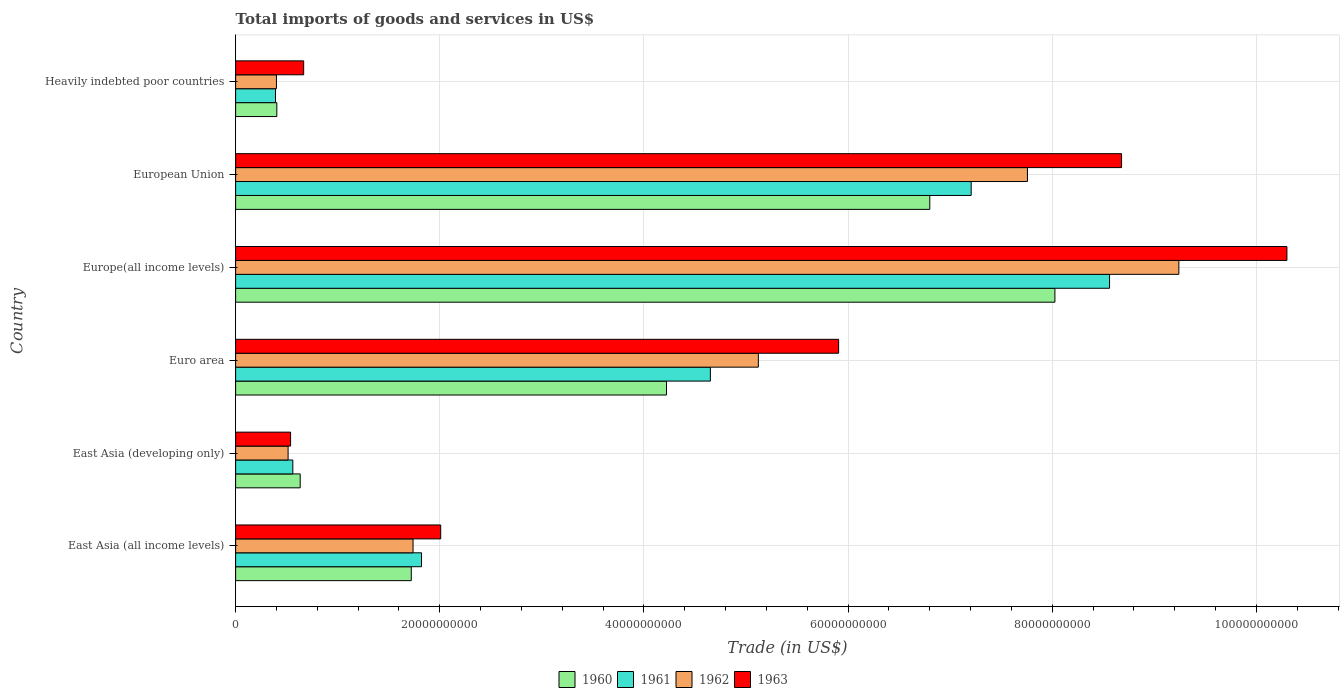How many different coloured bars are there?
Provide a succinct answer. 4. Are the number of bars on each tick of the Y-axis equal?
Your answer should be compact. Yes. How many bars are there on the 4th tick from the top?
Your response must be concise. 4. What is the label of the 1st group of bars from the top?
Provide a succinct answer. Heavily indebted poor countries. In how many cases, is the number of bars for a given country not equal to the number of legend labels?
Provide a short and direct response. 0. What is the total imports of goods and services in 1961 in Heavily indebted poor countries?
Give a very brief answer. 3.91e+09. Across all countries, what is the maximum total imports of goods and services in 1961?
Your answer should be compact. 8.56e+1. Across all countries, what is the minimum total imports of goods and services in 1961?
Ensure brevity in your answer.  3.91e+09. In which country was the total imports of goods and services in 1963 maximum?
Provide a short and direct response. Europe(all income levels). In which country was the total imports of goods and services in 1962 minimum?
Provide a succinct answer. Heavily indebted poor countries. What is the total total imports of goods and services in 1960 in the graph?
Make the answer very short. 2.18e+11. What is the difference between the total imports of goods and services in 1960 in East Asia (developing only) and that in Heavily indebted poor countries?
Give a very brief answer. 2.29e+09. What is the difference between the total imports of goods and services in 1962 in East Asia (developing only) and the total imports of goods and services in 1963 in East Asia (all income levels)?
Keep it short and to the point. -1.50e+1. What is the average total imports of goods and services in 1960 per country?
Your response must be concise. 3.63e+1. What is the difference between the total imports of goods and services in 1961 and total imports of goods and services in 1960 in East Asia (all income levels)?
Offer a terse response. 1.00e+09. What is the ratio of the total imports of goods and services in 1960 in Euro area to that in Heavily indebted poor countries?
Provide a short and direct response. 10.45. Is the total imports of goods and services in 1962 in Europe(all income levels) less than that in European Union?
Provide a short and direct response. No. What is the difference between the highest and the second highest total imports of goods and services in 1962?
Provide a short and direct response. 1.48e+1. What is the difference between the highest and the lowest total imports of goods and services in 1960?
Offer a very short reply. 7.62e+1. Is it the case that in every country, the sum of the total imports of goods and services in 1963 and total imports of goods and services in 1960 is greater than the sum of total imports of goods and services in 1961 and total imports of goods and services in 1962?
Make the answer very short. No. What does the 2nd bar from the top in East Asia (developing only) represents?
Your answer should be compact. 1962. What does the 4th bar from the bottom in East Asia (all income levels) represents?
Provide a short and direct response. 1963. Is it the case that in every country, the sum of the total imports of goods and services in 1963 and total imports of goods and services in 1960 is greater than the total imports of goods and services in 1962?
Offer a terse response. Yes. How many bars are there?
Provide a short and direct response. 24. How many countries are there in the graph?
Offer a terse response. 6. Does the graph contain any zero values?
Ensure brevity in your answer.  No. How many legend labels are there?
Ensure brevity in your answer.  4. What is the title of the graph?
Your answer should be compact. Total imports of goods and services in US$. Does "1962" appear as one of the legend labels in the graph?
Your answer should be compact. Yes. What is the label or title of the X-axis?
Make the answer very short. Trade (in US$). What is the Trade (in US$) of 1960 in East Asia (all income levels)?
Your answer should be compact. 1.72e+1. What is the Trade (in US$) of 1961 in East Asia (all income levels)?
Provide a succinct answer. 1.82e+1. What is the Trade (in US$) in 1962 in East Asia (all income levels)?
Make the answer very short. 1.74e+1. What is the Trade (in US$) of 1963 in East Asia (all income levels)?
Offer a terse response. 2.01e+1. What is the Trade (in US$) of 1960 in East Asia (developing only)?
Offer a terse response. 6.33e+09. What is the Trade (in US$) of 1961 in East Asia (developing only)?
Ensure brevity in your answer.  5.60e+09. What is the Trade (in US$) in 1962 in East Asia (developing only)?
Provide a succinct answer. 5.14e+09. What is the Trade (in US$) in 1963 in East Asia (developing only)?
Ensure brevity in your answer.  5.39e+09. What is the Trade (in US$) in 1960 in Euro area?
Offer a very short reply. 4.22e+1. What is the Trade (in US$) in 1961 in Euro area?
Your answer should be very brief. 4.65e+1. What is the Trade (in US$) of 1962 in Euro area?
Provide a short and direct response. 5.12e+1. What is the Trade (in US$) of 1963 in Euro area?
Offer a terse response. 5.91e+1. What is the Trade (in US$) of 1960 in Europe(all income levels)?
Offer a very short reply. 8.03e+1. What is the Trade (in US$) in 1961 in Europe(all income levels)?
Make the answer very short. 8.56e+1. What is the Trade (in US$) in 1962 in Europe(all income levels)?
Keep it short and to the point. 9.24e+1. What is the Trade (in US$) in 1963 in Europe(all income levels)?
Ensure brevity in your answer.  1.03e+11. What is the Trade (in US$) in 1960 in European Union?
Keep it short and to the point. 6.80e+1. What is the Trade (in US$) of 1961 in European Union?
Your answer should be compact. 7.21e+1. What is the Trade (in US$) of 1962 in European Union?
Your answer should be compact. 7.76e+1. What is the Trade (in US$) in 1963 in European Union?
Give a very brief answer. 8.68e+1. What is the Trade (in US$) in 1960 in Heavily indebted poor countries?
Provide a succinct answer. 4.04e+09. What is the Trade (in US$) of 1961 in Heavily indebted poor countries?
Your answer should be very brief. 3.91e+09. What is the Trade (in US$) of 1962 in Heavily indebted poor countries?
Provide a short and direct response. 4.00e+09. What is the Trade (in US$) in 1963 in Heavily indebted poor countries?
Provide a short and direct response. 6.67e+09. Across all countries, what is the maximum Trade (in US$) of 1960?
Ensure brevity in your answer.  8.03e+1. Across all countries, what is the maximum Trade (in US$) of 1961?
Your answer should be compact. 8.56e+1. Across all countries, what is the maximum Trade (in US$) of 1962?
Provide a short and direct response. 9.24e+1. Across all countries, what is the maximum Trade (in US$) of 1963?
Ensure brevity in your answer.  1.03e+11. Across all countries, what is the minimum Trade (in US$) in 1960?
Ensure brevity in your answer.  4.04e+09. Across all countries, what is the minimum Trade (in US$) of 1961?
Provide a short and direct response. 3.91e+09. Across all countries, what is the minimum Trade (in US$) of 1962?
Your answer should be compact. 4.00e+09. Across all countries, what is the minimum Trade (in US$) of 1963?
Keep it short and to the point. 5.39e+09. What is the total Trade (in US$) in 1960 in the graph?
Your answer should be compact. 2.18e+11. What is the total Trade (in US$) in 1961 in the graph?
Provide a succinct answer. 2.32e+11. What is the total Trade (in US$) in 1962 in the graph?
Offer a terse response. 2.48e+11. What is the total Trade (in US$) in 1963 in the graph?
Offer a very short reply. 2.81e+11. What is the difference between the Trade (in US$) in 1960 in East Asia (all income levels) and that in East Asia (developing only)?
Offer a very short reply. 1.09e+1. What is the difference between the Trade (in US$) in 1961 in East Asia (all income levels) and that in East Asia (developing only)?
Offer a very short reply. 1.26e+1. What is the difference between the Trade (in US$) of 1962 in East Asia (all income levels) and that in East Asia (developing only)?
Keep it short and to the point. 1.22e+1. What is the difference between the Trade (in US$) in 1963 in East Asia (all income levels) and that in East Asia (developing only)?
Ensure brevity in your answer.  1.47e+1. What is the difference between the Trade (in US$) in 1960 in East Asia (all income levels) and that in Euro area?
Keep it short and to the point. -2.50e+1. What is the difference between the Trade (in US$) in 1961 in East Asia (all income levels) and that in Euro area?
Your answer should be compact. -2.83e+1. What is the difference between the Trade (in US$) of 1962 in East Asia (all income levels) and that in Euro area?
Ensure brevity in your answer.  -3.38e+1. What is the difference between the Trade (in US$) of 1963 in East Asia (all income levels) and that in Euro area?
Offer a terse response. -3.90e+1. What is the difference between the Trade (in US$) of 1960 in East Asia (all income levels) and that in Europe(all income levels)?
Your answer should be compact. -6.31e+1. What is the difference between the Trade (in US$) in 1961 in East Asia (all income levels) and that in Europe(all income levels)?
Offer a terse response. -6.74e+1. What is the difference between the Trade (in US$) of 1962 in East Asia (all income levels) and that in Europe(all income levels)?
Ensure brevity in your answer.  -7.50e+1. What is the difference between the Trade (in US$) in 1963 in East Asia (all income levels) and that in Europe(all income levels)?
Give a very brief answer. -8.29e+1. What is the difference between the Trade (in US$) in 1960 in East Asia (all income levels) and that in European Union?
Provide a short and direct response. -5.08e+1. What is the difference between the Trade (in US$) in 1961 in East Asia (all income levels) and that in European Union?
Offer a very short reply. -5.38e+1. What is the difference between the Trade (in US$) in 1962 in East Asia (all income levels) and that in European Union?
Make the answer very short. -6.02e+1. What is the difference between the Trade (in US$) in 1963 in East Asia (all income levels) and that in European Union?
Your answer should be very brief. -6.67e+1. What is the difference between the Trade (in US$) in 1960 in East Asia (all income levels) and that in Heavily indebted poor countries?
Your answer should be compact. 1.32e+1. What is the difference between the Trade (in US$) in 1961 in East Asia (all income levels) and that in Heavily indebted poor countries?
Provide a short and direct response. 1.43e+1. What is the difference between the Trade (in US$) of 1962 in East Asia (all income levels) and that in Heavily indebted poor countries?
Your answer should be very brief. 1.34e+1. What is the difference between the Trade (in US$) in 1963 in East Asia (all income levels) and that in Heavily indebted poor countries?
Your answer should be compact. 1.34e+1. What is the difference between the Trade (in US$) of 1960 in East Asia (developing only) and that in Euro area?
Offer a terse response. -3.59e+1. What is the difference between the Trade (in US$) of 1961 in East Asia (developing only) and that in Euro area?
Keep it short and to the point. -4.09e+1. What is the difference between the Trade (in US$) in 1962 in East Asia (developing only) and that in Euro area?
Your answer should be very brief. -4.61e+1. What is the difference between the Trade (in US$) of 1963 in East Asia (developing only) and that in Euro area?
Ensure brevity in your answer.  -5.37e+1. What is the difference between the Trade (in US$) in 1960 in East Asia (developing only) and that in Europe(all income levels)?
Offer a very short reply. -7.39e+1. What is the difference between the Trade (in US$) of 1961 in East Asia (developing only) and that in Europe(all income levels)?
Provide a succinct answer. -8.00e+1. What is the difference between the Trade (in US$) of 1962 in East Asia (developing only) and that in Europe(all income levels)?
Offer a terse response. -8.73e+1. What is the difference between the Trade (in US$) in 1963 in East Asia (developing only) and that in Europe(all income levels)?
Offer a very short reply. -9.76e+1. What is the difference between the Trade (in US$) of 1960 in East Asia (developing only) and that in European Union?
Provide a short and direct response. -6.17e+1. What is the difference between the Trade (in US$) of 1961 in East Asia (developing only) and that in European Union?
Keep it short and to the point. -6.65e+1. What is the difference between the Trade (in US$) of 1962 in East Asia (developing only) and that in European Union?
Provide a short and direct response. -7.24e+1. What is the difference between the Trade (in US$) in 1963 in East Asia (developing only) and that in European Union?
Provide a short and direct response. -8.14e+1. What is the difference between the Trade (in US$) of 1960 in East Asia (developing only) and that in Heavily indebted poor countries?
Offer a terse response. 2.29e+09. What is the difference between the Trade (in US$) of 1961 in East Asia (developing only) and that in Heavily indebted poor countries?
Your answer should be very brief. 1.70e+09. What is the difference between the Trade (in US$) in 1962 in East Asia (developing only) and that in Heavily indebted poor countries?
Provide a short and direct response. 1.14e+09. What is the difference between the Trade (in US$) in 1963 in East Asia (developing only) and that in Heavily indebted poor countries?
Your answer should be compact. -1.28e+09. What is the difference between the Trade (in US$) of 1960 in Euro area and that in Europe(all income levels)?
Your response must be concise. -3.80e+1. What is the difference between the Trade (in US$) in 1961 in Euro area and that in Europe(all income levels)?
Ensure brevity in your answer.  -3.91e+1. What is the difference between the Trade (in US$) of 1962 in Euro area and that in Europe(all income levels)?
Your answer should be compact. -4.12e+1. What is the difference between the Trade (in US$) of 1963 in Euro area and that in Europe(all income levels)?
Provide a succinct answer. -4.39e+1. What is the difference between the Trade (in US$) in 1960 in Euro area and that in European Union?
Your response must be concise. -2.58e+1. What is the difference between the Trade (in US$) of 1961 in Euro area and that in European Union?
Offer a terse response. -2.56e+1. What is the difference between the Trade (in US$) in 1962 in Euro area and that in European Union?
Keep it short and to the point. -2.64e+1. What is the difference between the Trade (in US$) of 1963 in Euro area and that in European Union?
Offer a terse response. -2.77e+1. What is the difference between the Trade (in US$) in 1960 in Euro area and that in Heavily indebted poor countries?
Your answer should be very brief. 3.82e+1. What is the difference between the Trade (in US$) of 1961 in Euro area and that in Heavily indebted poor countries?
Your answer should be compact. 4.26e+1. What is the difference between the Trade (in US$) of 1962 in Euro area and that in Heavily indebted poor countries?
Offer a terse response. 4.72e+1. What is the difference between the Trade (in US$) in 1963 in Euro area and that in Heavily indebted poor countries?
Your answer should be very brief. 5.24e+1. What is the difference between the Trade (in US$) in 1960 in Europe(all income levels) and that in European Union?
Provide a succinct answer. 1.23e+1. What is the difference between the Trade (in US$) in 1961 in Europe(all income levels) and that in European Union?
Offer a terse response. 1.36e+1. What is the difference between the Trade (in US$) in 1962 in Europe(all income levels) and that in European Union?
Your answer should be compact. 1.48e+1. What is the difference between the Trade (in US$) in 1963 in Europe(all income levels) and that in European Union?
Give a very brief answer. 1.62e+1. What is the difference between the Trade (in US$) of 1960 in Europe(all income levels) and that in Heavily indebted poor countries?
Give a very brief answer. 7.62e+1. What is the difference between the Trade (in US$) in 1961 in Europe(all income levels) and that in Heavily indebted poor countries?
Keep it short and to the point. 8.17e+1. What is the difference between the Trade (in US$) in 1962 in Europe(all income levels) and that in Heavily indebted poor countries?
Offer a terse response. 8.84e+1. What is the difference between the Trade (in US$) in 1963 in Europe(all income levels) and that in Heavily indebted poor countries?
Your answer should be very brief. 9.63e+1. What is the difference between the Trade (in US$) of 1960 in European Union and that in Heavily indebted poor countries?
Offer a very short reply. 6.40e+1. What is the difference between the Trade (in US$) of 1961 in European Union and that in Heavily indebted poor countries?
Provide a short and direct response. 6.82e+1. What is the difference between the Trade (in US$) of 1962 in European Union and that in Heavily indebted poor countries?
Ensure brevity in your answer.  7.36e+1. What is the difference between the Trade (in US$) in 1963 in European Union and that in Heavily indebted poor countries?
Keep it short and to the point. 8.01e+1. What is the difference between the Trade (in US$) in 1960 in East Asia (all income levels) and the Trade (in US$) in 1961 in East Asia (developing only)?
Your answer should be very brief. 1.16e+1. What is the difference between the Trade (in US$) of 1960 in East Asia (all income levels) and the Trade (in US$) of 1962 in East Asia (developing only)?
Your answer should be very brief. 1.21e+1. What is the difference between the Trade (in US$) in 1960 in East Asia (all income levels) and the Trade (in US$) in 1963 in East Asia (developing only)?
Your answer should be compact. 1.18e+1. What is the difference between the Trade (in US$) in 1961 in East Asia (all income levels) and the Trade (in US$) in 1962 in East Asia (developing only)?
Give a very brief answer. 1.31e+1. What is the difference between the Trade (in US$) of 1961 in East Asia (all income levels) and the Trade (in US$) of 1963 in East Asia (developing only)?
Keep it short and to the point. 1.28e+1. What is the difference between the Trade (in US$) of 1962 in East Asia (all income levels) and the Trade (in US$) of 1963 in East Asia (developing only)?
Give a very brief answer. 1.20e+1. What is the difference between the Trade (in US$) of 1960 in East Asia (all income levels) and the Trade (in US$) of 1961 in Euro area?
Your answer should be very brief. -2.93e+1. What is the difference between the Trade (in US$) in 1960 in East Asia (all income levels) and the Trade (in US$) in 1962 in Euro area?
Ensure brevity in your answer.  -3.40e+1. What is the difference between the Trade (in US$) of 1960 in East Asia (all income levels) and the Trade (in US$) of 1963 in Euro area?
Keep it short and to the point. -4.19e+1. What is the difference between the Trade (in US$) of 1961 in East Asia (all income levels) and the Trade (in US$) of 1962 in Euro area?
Offer a very short reply. -3.30e+1. What is the difference between the Trade (in US$) in 1961 in East Asia (all income levels) and the Trade (in US$) in 1963 in Euro area?
Make the answer very short. -4.09e+1. What is the difference between the Trade (in US$) of 1962 in East Asia (all income levels) and the Trade (in US$) of 1963 in Euro area?
Give a very brief answer. -4.17e+1. What is the difference between the Trade (in US$) of 1960 in East Asia (all income levels) and the Trade (in US$) of 1961 in Europe(all income levels)?
Your answer should be compact. -6.84e+1. What is the difference between the Trade (in US$) in 1960 in East Asia (all income levels) and the Trade (in US$) in 1962 in Europe(all income levels)?
Your response must be concise. -7.52e+1. What is the difference between the Trade (in US$) in 1960 in East Asia (all income levels) and the Trade (in US$) in 1963 in Europe(all income levels)?
Your response must be concise. -8.58e+1. What is the difference between the Trade (in US$) in 1961 in East Asia (all income levels) and the Trade (in US$) in 1962 in Europe(all income levels)?
Provide a short and direct response. -7.42e+1. What is the difference between the Trade (in US$) of 1961 in East Asia (all income levels) and the Trade (in US$) of 1963 in Europe(all income levels)?
Provide a short and direct response. -8.48e+1. What is the difference between the Trade (in US$) in 1962 in East Asia (all income levels) and the Trade (in US$) in 1963 in Europe(all income levels)?
Your response must be concise. -8.56e+1. What is the difference between the Trade (in US$) of 1960 in East Asia (all income levels) and the Trade (in US$) of 1961 in European Union?
Give a very brief answer. -5.49e+1. What is the difference between the Trade (in US$) of 1960 in East Asia (all income levels) and the Trade (in US$) of 1962 in European Union?
Ensure brevity in your answer.  -6.04e+1. What is the difference between the Trade (in US$) of 1960 in East Asia (all income levels) and the Trade (in US$) of 1963 in European Union?
Your answer should be very brief. -6.96e+1. What is the difference between the Trade (in US$) in 1961 in East Asia (all income levels) and the Trade (in US$) in 1962 in European Union?
Provide a succinct answer. -5.94e+1. What is the difference between the Trade (in US$) in 1961 in East Asia (all income levels) and the Trade (in US$) in 1963 in European Union?
Your answer should be very brief. -6.86e+1. What is the difference between the Trade (in US$) in 1962 in East Asia (all income levels) and the Trade (in US$) in 1963 in European Union?
Offer a terse response. -6.94e+1. What is the difference between the Trade (in US$) in 1960 in East Asia (all income levels) and the Trade (in US$) in 1961 in Heavily indebted poor countries?
Make the answer very short. 1.33e+1. What is the difference between the Trade (in US$) in 1960 in East Asia (all income levels) and the Trade (in US$) in 1962 in Heavily indebted poor countries?
Your response must be concise. 1.32e+1. What is the difference between the Trade (in US$) of 1960 in East Asia (all income levels) and the Trade (in US$) of 1963 in Heavily indebted poor countries?
Make the answer very short. 1.05e+1. What is the difference between the Trade (in US$) in 1961 in East Asia (all income levels) and the Trade (in US$) in 1962 in Heavily indebted poor countries?
Ensure brevity in your answer.  1.42e+1. What is the difference between the Trade (in US$) of 1961 in East Asia (all income levels) and the Trade (in US$) of 1963 in Heavily indebted poor countries?
Your answer should be very brief. 1.15e+1. What is the difference between the Trade (in US$) of 1962 in East Asia (all income levels) and the Trade (in US$) of 1963 in Heavily indebted poor countries?
Keep it short and to the point. 1.07e+1. What is the difference between the Trade (in US$) in 1960 in East Asia (developing only) and the Trade (in US$) in 1961 in Euro area?
Provide a short and direct response. -4.02e+1. What is the difference between the Trade (in US$) of 1960 in East Asia (developing only) and the Trade (in US$) of 1962 in Euro area?
Your response must be concise. -4.49e+1. What is the difference between the Trade (in US$) of 1960 in East Asia (developing only) and the Trade (in US$) of 1963 in Euro area?
Give a very brief answer. -5.27e+1. What is the difference between the Trade (in US$) in 1961 in East Asia (developing only) and the Trade (in US$) in 1962 in Euro area?
Provide a succinct answer. -4.56e+1. What is the difference between the Trade (in US$) in 1961 in East Asia (developing only) and the Trade (in US$) in 1963 in Euro area?
Make the answer very short. -5.35e+1. What is the difference between the Trade (in US$) of 1962 in East Asia (developing only) and the Trade (in US$) of 1963 in Euro area?
Make the answer very short. -5.39e+1. What is the difference between the Trade (in US$) in 1960 in East Asia (developing only) and the Trade (in US$) in 1961 in Europe(all income levels)?
Make the answer very short. -7.93e+1. What is the difference between the Trade (in US$) of 1960 in East Asia (developing only) and the Trade (in US$) of 1962 in Europe(all income levels)?
Provide a succinct answer. -8.61e+1. What is the difference between the Trade (in US$) in 1960 in East Asia (developing only) and the Trade (in US$) in 1963 in Europe(all income levels)?
Your answer should be very brief. -9.67e+1. What is the difference between the Trade (in US$) of 1961 in East Asia (developing only) and the Trade (in US$) of 1962 in Europe(all income levels)?
Your answer should be very brief. -8.68e+1. What is the difference between the Trade (in US$) of 1961 in East Asia (developing only) and the Trade (in US$) of 1963 in Europe(all income levels)?
Your answer should be very brief. -9.74e+1. What is the difference between the Trade (in US$) of 1962 in East Asia (developing only) and the Trade (in US$) of 1963 in Europe(all income levels)?
Offer a terse response. -9.79e+1. What is the difference between the Trade (in US$) of 1960 in East Asia (developing only) and the Trade (in US$) of 1961 in European Union?
Keep it short and to the point. -6.57e+1. What is the difference between the Trade (in US$) of 1960 in East Asia (developing only) and the Trade (in US$) of 1962 in European Union?
Your response must be concise. -7.12e+1. What is the difference between the Trade (in US$) in 1960 in East Asia (developing only) and the Trade (in US$) in 1963 in European Union?
Ensure brevity in your answer.  -8.05e+1. What is the difference between the Trade (in US$) of 1961 in East Asia (developing only) and the Trade (in US$) of 1962 in European Union?
Your answer should be very brief. -7.20e+1. What is the difference between the Trade (in US$) of 1961 in East Asia (developing only) and the Trade (in US$) of 1963 in European Union?
Your response must be concise. -8.12e+1. What is the difference between the Trade (in US$) in 1962 in East Asia (developing only) and the Trade (in US$) in 1963 in European Union?
Provide a succinct answer. -8.17e+1. What is the difference between the Trade (in US$) in 1960 in East Asia (developing only) and the Trade (in US$) in 1961 in Heavily indebted poor countries?
Ensure brevity in your answer.  2.42e+09. What is the difference between the Trade (in US$) in 1960 in East Asia (developing only) and the Trade (in US$) in 1962 in Heavily indebted poor countries?
Provide a short and direct response. 2.33e+09. What is the difference between the Trade (in US$) of 1960 in East Asia (developing only) and the Trade (in US$) of 1963 in Heavily indebted poor countries?
Your answer should be very brief. -3.39e+08. What is the difference between the Trade (in US$) in 1961 in East Asia (developing only) and the Trade (in US$) in 1962 in Heavily indebted poor countries?
Give a very brief answer. 1.61e+09. What is the difference between the Trade (in US$) in 1961 in East Asia (developing only) and the Trade (in US$) in 1963 in Heavily indebted poor countries?
Give a very brief answer. -1.06e+09. What is the difference between the Trade (in US$) of 1962 in East Asia (developing only) and the Trade (in US$) of 1963 in Heavily indebted poor countries?
Give a very brief answer. -1.53e+09. What is the difference between the Trade (in US$) in 1960 in Euro area and the Trade (in US$) in 1961 in Europe(all income levels)?
Offer a terse response. -4.34e+1. What is the difference between the Trade (in US$) of 1960 in Euro area and the Trade (in US$) of 1962 in Europe(all income levels)?
Provide a short and direct response. -5.02e+1. What is the difference between the Trade (in US$) in 1960 in Euro area and the Trade (in US$) in 1963 in Europe(all income levels)?
Make the answer very short. -6.08e+1. What is the difference between the Trade (in US$) in 1961 in Euro area and the Trade (in US$) in 1962 in Europe(all income levels)?
Provide a succinct answer. -4.59e+1. What is the difference between the Trade (in US$) in 1961 in Euro area and the Trade (in US$) in 1963 in Europe(all income levels)?
Provide a succinct answer. -5.65e+1. What is the difference between the Trade (in US$) of 1962 in Euro area and the Trade (in US$) of 1963 in Europe(all income levels)?
Provide a succinct answer. -5.18e+1. What is the difference between the Trade (in US$) in 1960 in Euro area and the Trade (in US$) in 1961 in European Union?
Offer a very short reply. -2.98e+1. What is the difference between the Trade (in US$) of 1960 in Euro area and the Trade (in US$) of 1962 in European Union?
Your answer should be compact. -3.54e+1. What is the difference between the Trade (in US$) in 1960 in Euro area and the Trade (in US$) in 1963 in European Union?
Offer a very short reply. -4.46e+1. What is the difference between the Trade (in US$) of 1961 in Euro area and the Trade (in US$) of 1962 in European Union?
Make the answer very short. -3.11e+1. What is the difference between the Trade (in US$) of 1961 in Euro area and the Trade (in US$) of 1963 in European Union?
Offer a very short reply. -4.03e+1. What is the difference between the Trade (in US$) in 1962 in Euro area and the Trade (in US$) in 1963 in European Union?
Provide a succinct answer. -3.56e+1. What is the difference between the Trade (in US$) in 1960 in Euro area and the Trade (in US$) in 1961 in Heavily indebted poor countries?
Offer a terse response. 3.83e+1. What is the difference between the Trade (in US$) of 1960 in Euro area and the Trade (in US$) of 1962 in Heavily indebted poor countries?
Ensure brevity in your answer.  3.82e+1. What is the difference between the Trade (in US$) of 1960 in Euro area and the Trade (in US$) of 1963 in Heavily indebted poor countries?
Give a very brief answer. 3.55e+1. What is the difference between the Trade (in US$) of 1961 in Euro area and the Trade (in US$) of 1962 in Heavily indebted poor countries?
Keep it short and to the point. 4.25e+1. What is the difference between the Trade (in US$) in 1961 in Euro area and the Trade (in US$) in 1963 in Heavily indebted poor countries?
Give a very brief answer. 3.98e+1. What is the difference between the Trade (in US$) of 1962 in Euro area and the Trade (in US$) of 1963 in Heavily indebted poor countries?
Keep it short and to the point. 4.45e+1. What is the difference between the Trade (in US$) in 1960 in Europe(all income levels) and the Trade (in US$) in 1961 in European Union?
Ensure brevity in your answer.  8.20e+09. What is the difference between the Trade (in US$) of 1960 in Europe(all income levels) and the Trade (in US$) of 1962 in European Union?
Your answer should be compact. 2.69e+09. What is the difference between the Trade (in US$) of 1960 in Europe(all income levels) and the Trade (in US$) of 1963 in European Union?
Provide a succinct answer. -6.53e+09. What is the difference between the Trade (in US$) of 1961 in Europe(all income levels) and the Trade (in US$) of 1962 in European Union?
Offer a terse response. 8.04e+09. What is the difference between the Trade (in US$) of 1961 in Europe(all income levels) and the Trade (in US$) of 1963 in European Union?
Give a very brief answer. -1.18e+09. What is the difference between the Trade (in US$) in 1962 in Europe(all income levels) and the Trade (in US$) in 1963 in European Union?
Provide a short and direct response. 5.61e+09. What is the difference between the Trade (in US$) of 1960 in Europe(all income levels) and the Trade (in US$) of 1961 in Heavily indebted poor countries?
Your answer should be very brief. 7.64e+1. What is the difference between the Trade (in US$) of 1960 in Europe(all income levels) and the Trade (in US$) of 1962 in Heavily indebted poor countries?
Your answer should be compact. 7.63e+1. What is the difference between the Trade (in US$) of 1960 in Europe(all income levels) and the Trade (in US$) of 1963 in Heavily indebted poor countries?
Your response must be concise. 7.36e+1. What is the difference between the Trade (in US$) in 1961 in Europe(all income levels) and the Trade (in US$) in 1962 in Heavily indebted poor countries?
Your answer should be very brief. 8.16e+1. What is the difference between the Trade (in US$) of 1961 in Europe(all income levels) and the Trade (in US$) of 1963 in Heavily indebted poor countries?
Your response must be concise. 7.90e+1. What is the difference between the Trade (in US$) in 1962 in Europe(all income levels) and the Trade (in US$) in 1963 in Heavily indebted poor countries?
Provide a succinct answer. 8.57e+1. What is the difference between the Trade (in US$) of 1960 in European Union and the Trade (in US$) of 1961 in Heavily indebted poor countries?
Offer a very short reply. 6.41e+1. What is the difference between the Trade (in US$) of 1960 in European Union and the Trade (in US$) of 1962 in Heavily indebted poor countries?
Ensure brevity in your answer.  6.40e+1. What is the difference between the Trade (in US$) in 1960 in European Union and the Trade (in US$) in 1963 in Heavily indebted poor countries?
Provide a short and direct response. 6.13e+1. What is the difference between the Trade (in US$) in 1961 in European Union and the Trade (in US$) in 1962 in Heavily indebted poor countries?
Your response must be concise. 6.81e+1. What is the difference between the Trade (in US$) of 1961 in European Union and the Trade (in US$) of 1963 in Heavily indebted poor countries?
Give a very brief answer. 6.54e+1. What is the difference between the Trade (in US$) of 1962 in European Union and the Trade (in US$) of 1963 in Heavily indebted poor countries?
Keep it short and to the point. 7.09e+1. What is the average Trade (in US$) of 1960 per country?
Offer a very short reply. 3.63e+1. What is the average Trade (in US$) in 1961 per country?
Your answer should be very brief. 3.87e+1. What is the average Trade (in US$) of 1962 per country?
Keep it short and to the point. 4.13e+1. What is the average Trade (in US$) in 1963 per country?
Give a very brief answer. 4.68e+1. What is the difference between the Trade (in US$) in 1960 and Trade (in US$) in 1961 in East Asia (all income levels)?
Offer a very short reply. -1.00e+09. What is the difference between the Trade (in US$) of 1960 and Trade (in US$) of 1962 in East Asia (all income levels)?
Ensure brevity in your answer.  -1.73e+08. What is the difference between the Trade (in US$) in 1960 and Trade (in US$) in 1963 in East Asia (all income levels)?
Your answer should be very brief. -2.88e+09. What is the difference between the Trade (in US$) in 1961 and Trade (in US$) in 1962 in East Asia (all income levels)?
Your response must be concise. 8.30e+08. What is the difference between the Trade (in US$) of 1961 and Trade (in US$) of 1963 in East Asia (all income levels)?
Your answer should be very brief. -1.88e+09. What is the difference between the Trade (in US$) in 1962 and Trade (in US$) in 1963 in East Asia (all income levels)?
Your answer should be compact. -2.71e+09. What is the difference between the Trade (in US$) in 1960 and Trade (in US$) in 1961 in East Asia (developing only)?
Ensure brevity in your answer.  7.24e+08. What is the difference between the Trade (in US$) of 1960 and Trade (in US$) of 1962 in East Asia (developing only)?
Offer a terse response. 1.19e+09. What is the difference between the Trade (in US$) of 1960 and Trade (in US$) of 1963 in East Asia (developing only)?
Offer a very short reply. 9.42e+08. What is the difference between the Trade (in US$) in 1961 and Trade (in US$) in 1962 in East Asia (developing only)?
Your answer should be compact. 4.63e+08. What is the difference between the Trade (in US$) of 1961 and Trade (in US$) of 1963 in East Asia (developing only)?
Offer a very short reply. 2.18e+08. What is the difference between the Trade (in US$) of 1962 and Trade (in US$) of 1963 in East Asia (developing only)?
Your answer should be compact. -2.45e+08. What is the difference between the Trade (in US$) of 1960 and Trade (in US$) of 1961 in Euro area?
Provide a succinct answer. -4.30e+09. What is the difference between the Trade (in US$) in 1960 and Trade (in US$) in 1962 in Euro area?
Give a very brief answer. -9.00e+09. What is the difference between the Trade (in US$) in 1960 and Trade (in US$) in 1963 in Euro area?
Provide a short and direct response. -1.69e+1. What is the difference between the Trade (in US$) of 1961 and Trade (in US$) of 1962 in Euro area?
Offer a very short reply. -4.70e+09. What is the difference between the Trade (in US$) in 1961 and Trade (in US$) in 1963 in Euro area?
Keep it short and to the point. -1.26e+1. What is the difference between the Trade (in US$) of 1962 and Trade (in US$) of 1963 in Euro area?
Your response must be concise. -7.86e+09. What is the difference between the Trade (in US$) of 1960 and Trade (in US$) of 1961 in Europe(all income levels)?
Provide a succinct answer. -5.35e+09. What is the difference between the Trade (in US$) in 1960 and Trade (in US$) in 1962 in Europe(all income levels)?
Give a very brief answer. -1.21e+1. What is the difference between the Trade (in US$) of 1960 and Trade (in US$) of 1963 in Europe(all income levels)?
Your answer should be compact. -2.27e+1. What is the difference between the Trade (in US$) of 1961 and Trade (in US$) of 1962 in Europe(all income levels)?
Keep it short and to the point. -6.79e+09. What is the difference between the Trade (in US$) of 1961 and Trade (in US$) of 1963 in Europe(all income levels)?
Ensure brevity in your answer.  -1.74e+1. What is the difference between the Trade (in US$) of 1962 and Trade (in US$) of 1963 in Europe(all income levels)?
Give a very brief answer. -1.06e+1. What is the difference between the Trade (in US$) in 1960 and Trade (in US$) in 1961 in European Union?
Ensure brevity in your answer.  -4.05e+09. What is the difference between the Trade (in US$) of 1960 and Trade (in US$) of 1962 in European Union?
Provide a short and direct response. -9.57e+09. What is the difference between the Trade (in US$) of 1960 and Trade (in US$) of 1963 in European Union?
Offer a terse response. -1.88e+1. What is the difference between the Trade (in US$) of 1961 and Trade (in US$) of 1962 in European Union?
Offer a very short reply. -5.51e+09. What is the difference between the Trade (in US$) in 1961 and Trade (in US$) in 1963 in European Union?
Offer a terse response. -1.47e+1. What is the difference between the Trade (in US$) of 1962 and Trade (in US$) of 1963 in European Union?
Offer a terse response. -9.22e+09. What is the difference between the Trade (in US$) in 1960 and Trade (in US$) in 1961 in Heavily indebted poor countries?
Offer a very short reply. 1.30e+08. What is the difference between the Trade (in US$) in 1960 and Trade (in US$) in 1962 in Heavily indebted poor countries?
Provide a short and direct response. 3.87e+07. What is the difference between the Trade (in US$) of 1960 and Trade (in US$) of 1963 in Heavily indebted poor countries?
Provide a succinct answer. -2.63e+09. What is the difference between the Trade (in US$) of 1961 and Trade (in US$) of 1962 in Heavily indebted poor countries?
Your answer should be very brief. -9.18e+07. What is the difference between the Trade (in US$) of 1961 and Trade (in US$) of 1963 in Heavily indebted poor countries?
Make the answer very short. -2.76e+09. What is the difference between the Trade (in US$) in 1962 and Trade (in US$) in 1963 in Heavily indebted poor countries?
Offer a terse response. -2.67e+09. What is the ratio of the Trade (in US$) in 1960 in East Asia (all income levels) to that in East Asia (developing only)?
Ensure brevity in your answer.  2.72. What is the ratio of the Trade (in US$) of 1961 in East Asia (all income levels) to that in East Asia (developing only)?
Provide a succinct answer. 3.25. What is the ratio of the Trade (in US$) of 1962 in East Asia (all income levels) to that in East Asia (developing only)?
Provide a short and direct response. 3.38. What is the ratio of the Trade (in US$) of 1963 in East Asia (all income levels) to that in East Asia (developing only)?
Offer a terse response. 3.73. What is the ratio of the Trade (in US$) of 1960 in East Asia (all income levels) to that in Euro area?
Your response must be concise. 0.41. What is the ratio of the Trade (in US$) of 1961 in East Asia (all income levels) to that in Euro area?
Make the answer very short. 0.39. What is the ratio of the Trade (in US$) in 1962 in East Asia (all income levels) to that in Euro area?
Your answer should be compact. 0.34. What is the ratio of the Trade (in US$) in 1963 in East Asia (all income levels) to that in Euro area?
Keep it short and to the point. 0.34. What is the ratio of the Trade (in US$) of 1960 in East Asia (all income levels) to that in Europe(all income levels)?
Offer a terse response. 0.21. What is the ratio of the Trade (in US$) in 1961 in East Asia (all income levels) to that in Europe(all income levels)?
Keep it short and to the point. 0.21. What is the ratio of the Trade (in US$) of 1962 in East Asia (all income levels) to that in Europe(all income levels)?
Keep it short and to the point. 0.19. What is the ratio of the Trade (in US$) of 1963 in East Asia (all income levels) to that in Europe(all income levels)?
Your response must be concise. 0.2. What is the ratio of the Trade (in US$) in 1960 in East Asia (all income levels) to that in European Union?
Your answer should be compact. 0.25. What is the ratio of the Trade (in US$) in 1961 in East Asia (all income levels) to that in European Union?
Your response must be concise. 0.25. What is the ratio of the Trade (in US$) of 1962 in East Asia (all income levels) to that in European Union?
Your answer should be very brief. 0.22. What is the ratio of the Trade (in US$) in 1963 in East Asia (all income levels) to that in European Union?
Ensure brevity in your answer.  0.23. What is the ratio of the Trade (in US$) of 1960 in East Asia (all income levels) to that in Heavily indebted poor countries?
Ensure brevity in your answer.  4.26. What is the ratio of the Trade (in US$) of 1961 in East Asia (all income levels) to that in Heavily indebted poor countries?
Provide a short and direct response. 4.66. What is the ratio of the Trade (in US$) in 1962 in East Asia (all income levels) to that in Heavily indebted poor countries?
Your response must be concise. 4.35. What is the ratio of the Trade (in US$) in 1963 in East Asia (all income levels) to that in Heavily indebted poor countries?
Your response must be concise. 3.01. What is the ratio of the Trade (in US$) in 1960 in East Asia (developing only) to that in Euro area?
Offer a very short reply. 0.15. What is the ratio of the Trade (in US$) in 1961 in East Asia (developing only) to that in Euro area?
Give a very brief answer. 0.12. What is the ratio of the Trade (in US$) of 1962 in East Asia (developing only) to that in Euro area?
Your response must be concise. 0.1. What is the ratio of the Trade (in US$) in 1963 in East Asia (developing only) to that in Euro area?
Your answer should be compact. 0.09. What is the ratio of the Trade (in US$) of 1960 in East Asia (developing only) to that in Europe(all income levels)?
Your answer should be very brief. 0.08. What is the ratio of the Trade (in US$) in 1961 in East Asia (developing only) to that in Europe(all income levels)?
Make the answer very short. 0.07. What is the ratio of the Trade (in US$) in 1962 in East Asia (developing only) to that in Europe(all income levels)?
Your response must be concise. 0.06. What is the ratio of the Trade (in US$) of 1963 in East Asia (developing only) to that in Europe(all income levels)?
Provide a short and direct response. 0.05. What is the ratio of the Trade (in US$) of 1960 in East Asia (developing only) to that in European Union?
Make the answer very short. 0.09. What is the ratio of the Trade (in US$) in 1961 in East Asia (developing only) to that in European Union?
Give a very brief answer. 0.08. What is the ratio of the Trade (in US$) of 1962 in East Asia (developing only) to that in European Union?
Your answer should be compact. 0.07. What is the ratio of the Trade (in US$) in 1963 in East Asia (developing only) to that in European Union?
Ensure brevity in your answer.  0.06. What is the ratio of the Trade (in US$) in 1960 in East Asia (developing only) to that in Heavily indebted poor countries?
Offer a terse response. 1.57. What is the ratio of the Trade (in US$) of 1961 in East Asia (developing only) to that in Heavily indebted poor countries?
Offer a terse response. 1.43. What is the ratio of the Trade (in US$) of 1962 in East Asia (developing only) to that in Heavily indebted poor countries?
Offer a terse response. 1.29. What is the ratio of the Trade (in US$) in 1963 in East Asia (developing only) to that in Heavily indebted poor countries?
Provide a short and direct response. 0.81. What is the ratio of the Trade (in US$) in 1960 in Euro area to that in Europe(all income levels)?
Your response must be concise. 0.53. What is the ratio of the Trade (in US$) of 1961 in Euro area to that in Europe(all income levels)?
Your response must be concise. 0.54. What is the ratio of the Trade (in US$) of 1962 in Euro area to that in Europe(all income levels)?
Your answer should be very brief. 0.55. What is the ratio of the Trade (in US$) in 1963 in Euro area to that in Europe(all income levels)?
Keep it short and to the point. 0.57. What is the ratio of the Trade (in US$) of 1960 in Euro area to that in European Union?
Give a very brief answer. 0.62. What is the ratio of the Trade (in US$) of 1961 in Euro area to that in European Union?
Provide a succinct answer. 0.65. What is the ratio of the Trade (in US$) of 1962 in Euro area to that in European Union?
Your response must be concise. 0.66. What is the ratio of the Trade (in US$) of 1963 in Euro area to that in European Union?
Make the answer very short. 0.68. What is the ratio of the Trade (in US$) in 1960 in Euro area to that in Heavily indebted poor countries?
Your answer should be very brief. 10.45. What is the ratio of the Trade (in US$) in 1961 in Euro area to that in Heavily indebted poor countries?
Offer a very short reply. 11.9. What is the ratio of the Trade (in US$) of 1962 in Euro area to that in Heavily indebted poor countries?
Offer a terse response. 12.81. What is the ratio of the Trade (in US$) in 1963 in Euro area to that in Heavily indebted poor countries?
Make the answer very short. 8.86. What is the ratio of the Trade (in US$) of 1960 in Europe(all income levels) to that in European Union?
Make the answer very short. 1.18. What is the ratio of the Trade (in US$) in 1961 in Europe(all income levels) to that in European Union?
Ensure brevity in your answer.  1.19. What is the ratio of the Trade (in US$) of 1962 in Europe(all income levels) to that in European Union?
Your response must be concise. 1.19. What is the ratio of the Trade (in US$) of 1963 in Europe(all income levels) to that in European Union?
Your answer should be very brief. 1.19. What is the ratio of the Trade (in US$) in 1960 in Europe(all income levels) to that in Heavily indebted poor countries?
Give a very brief answer. 19.88. What is the ratio of the Trade (in US$) in 1961 in Europe(all income levels) to that in Heavily indebted poor countries?
Offer a terse response. 21.91. What is the ratio of the Trade (in US$) in 1962 in Europe(all income levels) to that in Heavily indebted poor countries?
Offer a very short reply. 23.11. What is the ratio of the Trade (in US$) in 1963 in Europe(all income levels) to that in Heavily indebted poor countries?
Your answer should be compact. 15.45. What is the ratio of the Trade (in US$) of 1960 in European Union to that in Heavily indebted poor countries?
Your answer should be very brief. 16.84. What is the ratio of the Trade (in US$) of 1961 in European Union to that in Heavily indebted poor countries?
Offer a very short reply. 18.44. What is the ratio of the Trade (in US$) in 1962 in European Union to that in Heavily indebted poor countries?
Your answer should be compact. 19.4. What is the ratio of the Trade (in US$) of 1963 in European Union to that in Heavily indebted poor countries?
Provide a short and direct response. 13.02. What is the difference between the highest and the second highest Trade (in US$) of 1960?
Offer a terse response. 1.23e+1. What is the difference between the highest and the second highest Trade (in US$) in 1961?
Provide a succinct answer. 1.36e+1. What is the difference between the highest and the second highest Trade (in US$) of 1962?
Offer a very short reply. 1.48e+1. What is the difference between the highest and the second highest Trade (in US$) in 1963?
Offer a very short reply. 1.62e+1. What is the difference between the highest and the lowest Trade (in US$) in 1960?
Offer a terse response. 7.62e+1. What is the difference between the highest and the lowest Trade (in US$) of 1961?
Your answer should be compact. 8.17e+1. What is the difference between the highest and the lowest Trade (in US$) of 1962?
Make the answer very short. 8.84e+1. What is the difference between the highest and the lowest Trade (in US$) in 1963?
Offer a very short reply. 9.76e+1. 